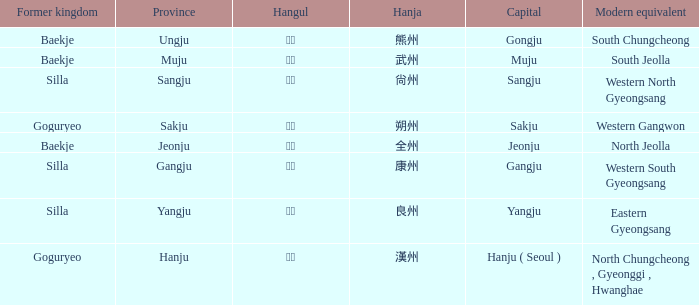Which province is associated with the hanja 朔州? Sakju. 